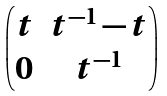Convert formula to latex. <formula><loc_0><loc_0><loc_500><loc_500>\begin{pmatrix} t & t ^ { - 1 } - t \\ 0 & t ^ { - 1 } \end{pmatrix}</formula> 